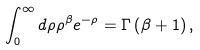<formula> <loc_0><loc_0><loc_500><loc_500>\int _ { 0 } ^ { \infty } d \rho \rho ^ { \beta } e ^ { - \rho } = \Gamma \left ( \beta + 1 \right ) ,</formula> 